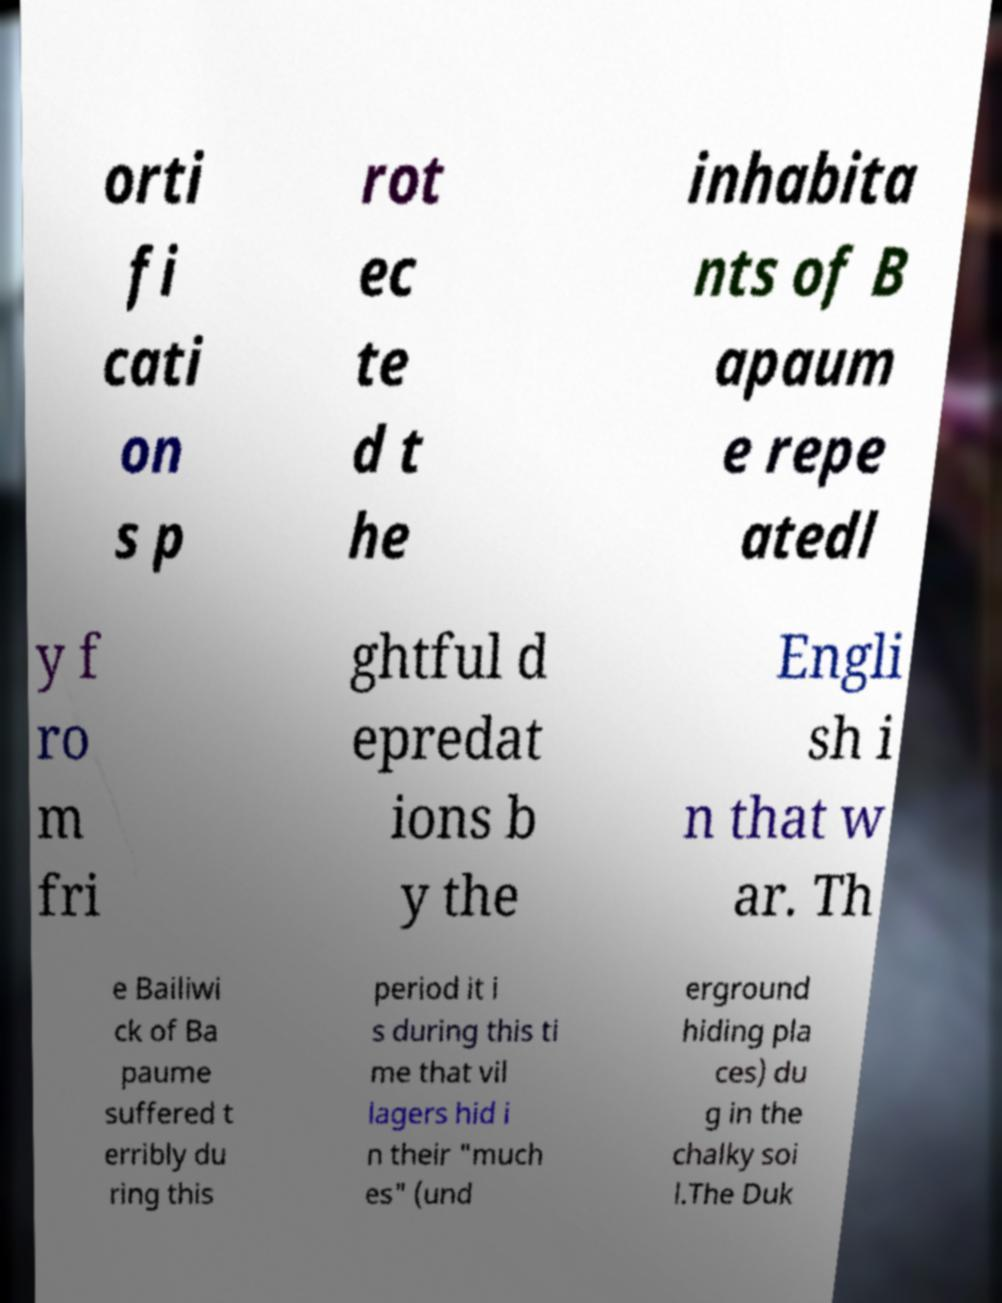I need the written content from this picture converted into text. Can you do that? orti fi cati on s p rot ec te d t he inhabita nts of B apaum e repe atedl y f ro m fri ghtful d epredat ions b y the Engli sh i n that w ar. Th e Bailiwi ck of Ba paume suffered t erribly du ring this period it i s during this ti me that vil lagers hid i n their "much es" (und erground hiding pla ces) du g in the chalky soi l.The Duk 